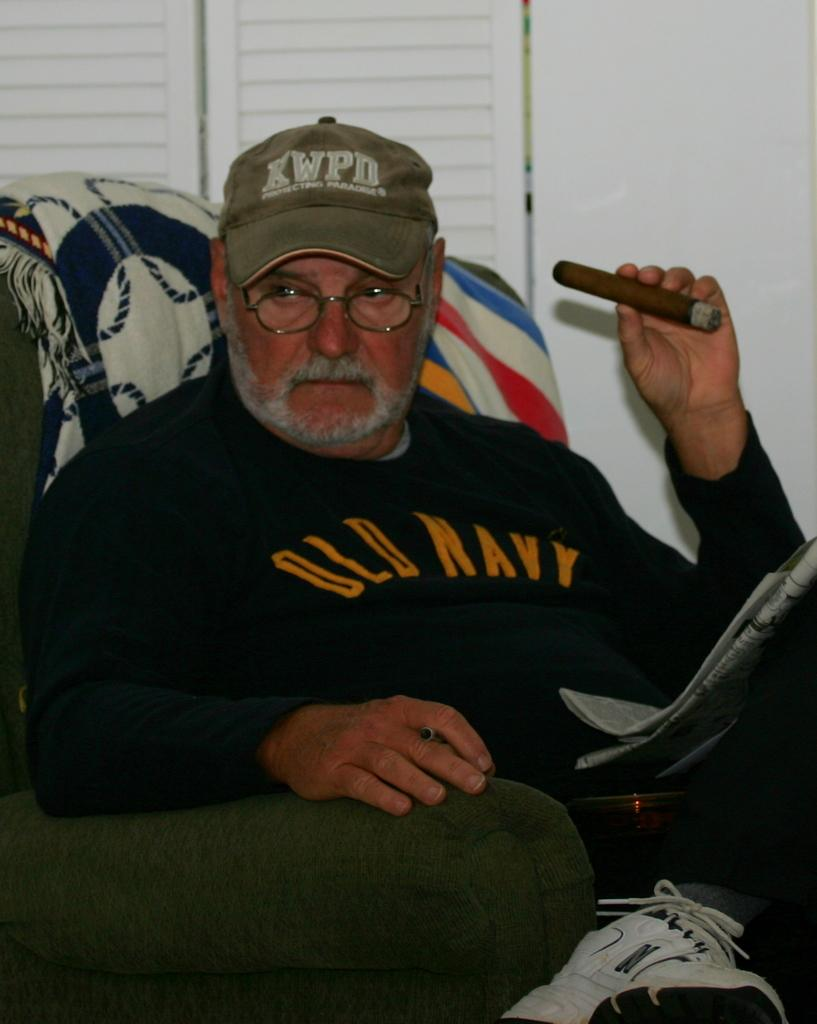<image>
Describe the image concisely. An older male with an old navy sweater on. 